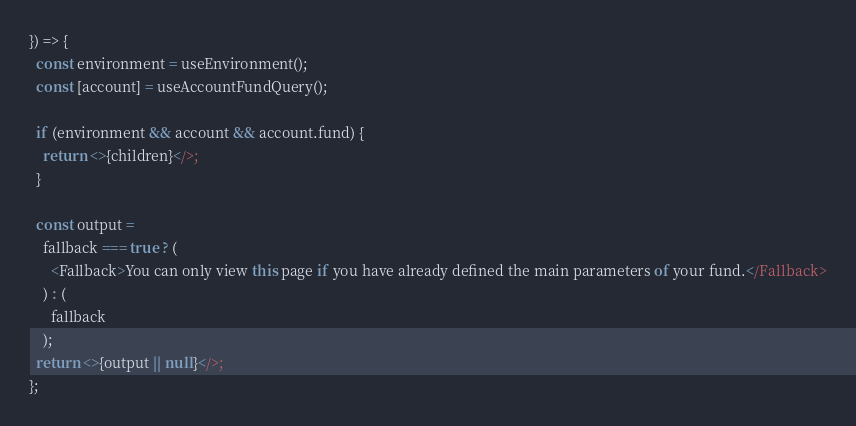Convert code to text. <code><loc_0><loc_0><loc_500><loc_500><_TypeScript_>}) => {
  const environment = useEnvironment();
  const [account] = useAccountFundQuery();

  if (environment && account && account.fund) {
    return <>{children}</>;
  }

  const output =
    fallback === true ? (
      <Fallback>You can only view this page if you have already defined the main parameters of your fund.</Fallback>
    ) : (
      fallback
    );
  return <>{output || null}</>;
};
</code> 